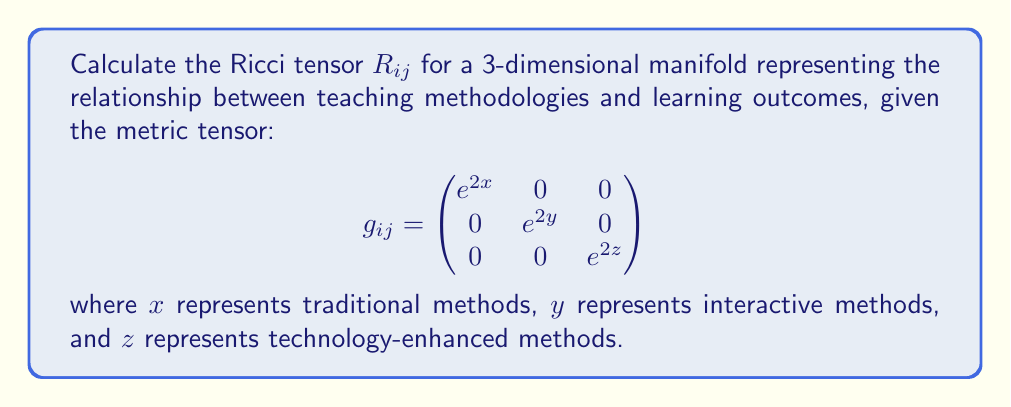What is the answer to this math problem? To calculate the Ricci tensor, we need to follow these steps:

1. Calculate the Christoffel symbols $\Gamma^k_{ij}$:
   $$\Gamma^k_{ij} = \frac{1}{2}g^{kl}(\partial_i g_{jl} + \partial_j g_{il} - \partial_l g_{ij})$$

2. Calculate the Riemann curvature tensor $R^i_{jkl}$:
   $$R^i_{jkl} = \partial_k \Gamma^i_{jl} - \partial_l \Gamma^i_{jk} + \Gamma^i_{km}\Gamma^m_{jl} - \Gamma^i_{lm}\Gamma^m_{jk}$$

3. Contract the Riemann tensor to get the Ricci tensor $R_{ij}$:
   $$R_{ij} = R^k_{ikj}$$

Step 1: Calculating Christoffel symbols

The non-zero Christoffel symbols are:
$$\Gamma^1_{11} = 1, \quad \Gamma^2_{22} = 1, \quad \Gamma^3_{33} = 1$$

Step 2: Calculating Riemann curvature tensor

The non-zero components of the Riemann tensor are:
$$R^1_{221} = -e^{2(x-y)}, \quad R^1_{331} = -e^{2(x-z)}$$
$$R^2_{112} = -e^{2(y-x)}, \quad R^2_{332} = -e^{2(y-z)}$$
$$R^3_{113} = -e^{2(z-x)}, \quad R^3_{223} = -e^{2(z-y)}$$

Step 3: Contracting to get Ricci tensor

$$R_{11} = R^2_{121} + R^3_{131} = -e^{2(x-y)} - e^{2(x-z)}$$
$$R_{22} = R^1_{212} + R^3_{232} = -e^{2(y-x)} - e^{2(y-z)}$$
$$R_{33} = R^1_{313} + R^2_{323} = -e^{2(z-x)} - e^{2(z-y)}$$

All other components are zero.
Answer: $$R_{ij} = \begin{pmatrix}
-e^{2(x-y)} - e^{2(x-z)} & 0 & 0 \\
0 & -e^{2(y-x)} - e^{2(y-z)} & 0 \\
0 & 0 & -e^{2(z-x)} - e^{2(z-y)}
\end{pmatrix}$$ 